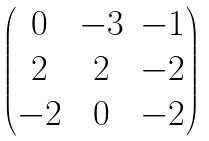<formula> <loc_0><loc_0><loc_500><loc_500>\begin{pmatrix} 0 & - 3 & - 1 \\ 2 & 2 & - 2 \\ - 2 & 0 & - 2 \end{pmatrix}</formula> 